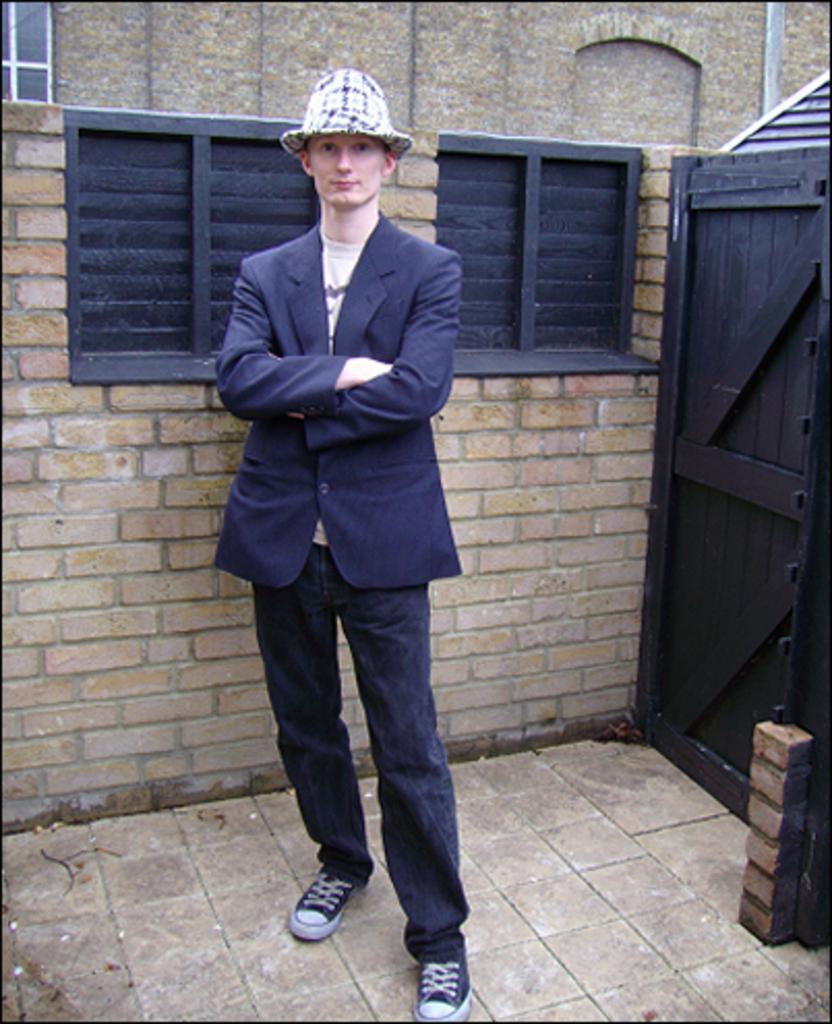Describe this image in one or two sentences. There is a person in a suit, wearing a cap and standing on the floor near wall, which is having windows. On the right side, there is a door. In the background, there is a building which is having glass window. 